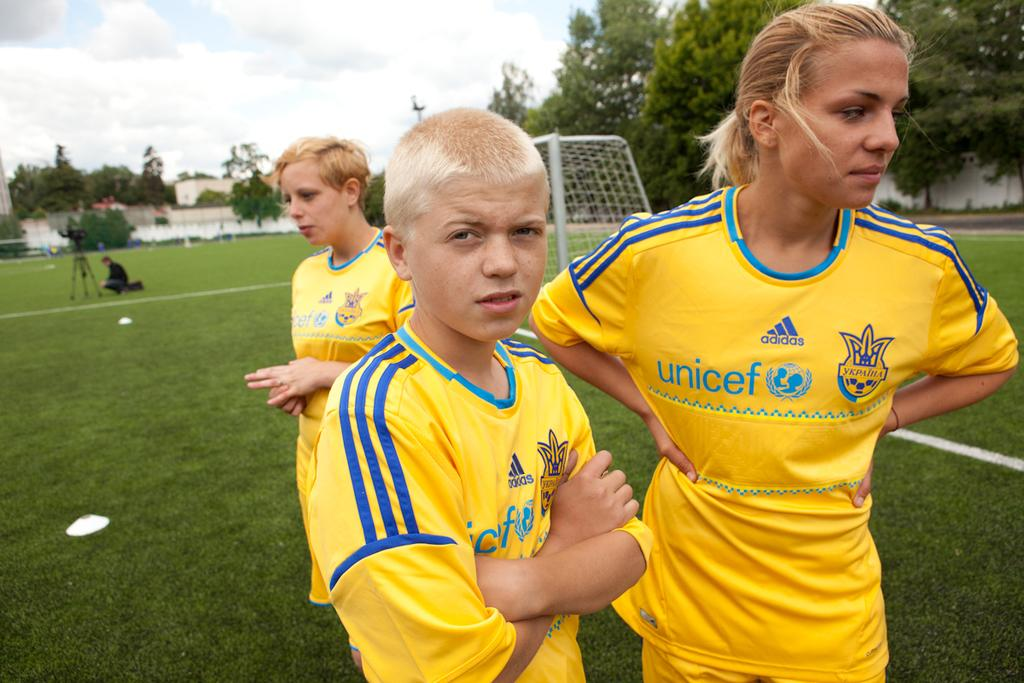<image>
Give a short and clear explanation of the subsequent image. Three players with Unicef on their uniforms wait on the field. 